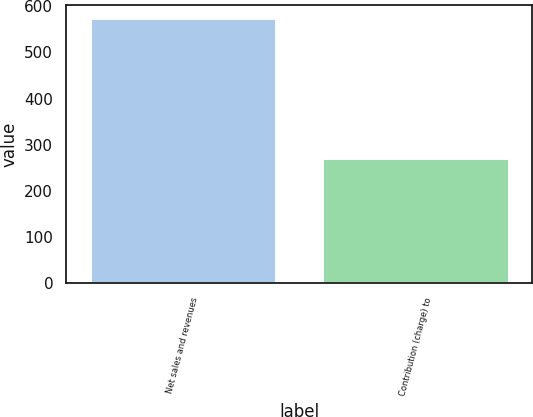<chart> <loc_0><loc_0><loc_500><loc_500><bar_chart><fcel>Net sales and revenues<fcel>Contribution (charge) to<nl><fcel>575<fcel>271<nl></chart> 